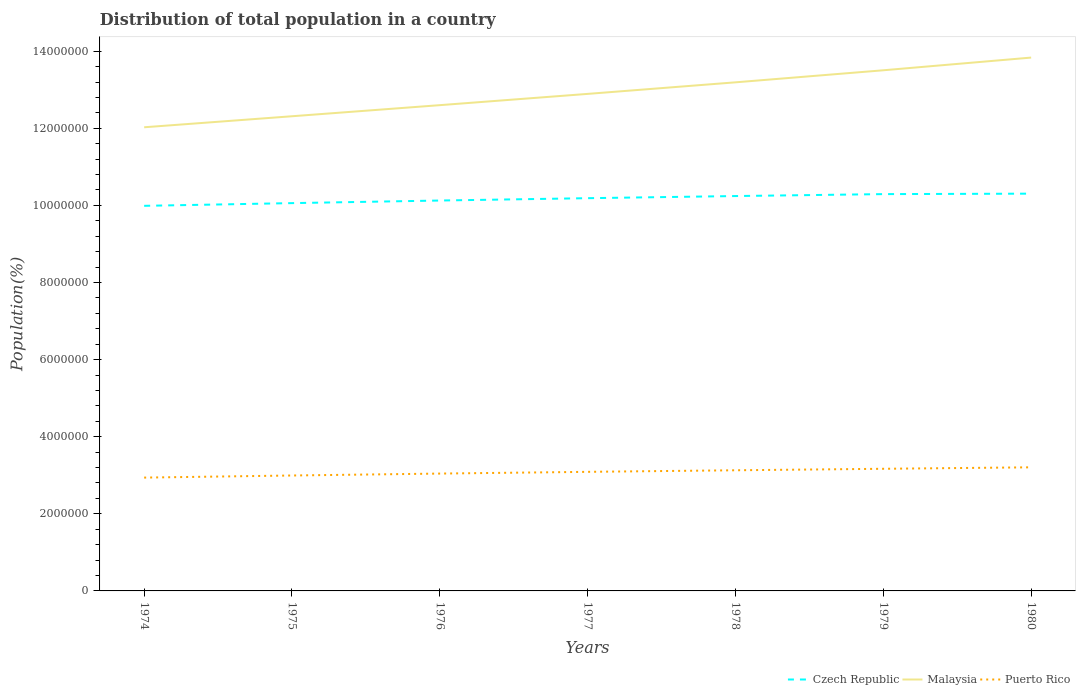How many different coloured lines are there?
Offer a very short reply. 3. Does the line corresponding to Malaysia intersect with the line corresponding to Czech Republic?
Offer a terse response. No. Is the number of lines equal to the number of legend labels?
Offer a terse response. Yes. Across all years, what is the maximum population of in Puerto Rico?
Provide a short and direct response. 2.94e+06. In which year was the population of in Malaysia maximum?
Offer a terse response. 1974. What is the total population of in Puerto Rico in the graph?
Keep it short and to the point. -7.94e+04. What is the difference between the highest and the second highest population of in Malaysia?
Give a very brief answer. 1.81e+06. What is the difference between the highest and the lowest population of in Puerto Rico?
Keep it short and to the point. 4. Is the population of in Czech Republic strictly greater than the population of in Puerto Rico over the years?
Offer a very short reply. No. How many lines are there?
Ensure brevity in your answer.  3. What is the difference between two consecutive major ticks on the Y-axis?
Keep it short and to the point. 2.00e+06. Does the graph contain grids?
Your response must be concise. No. Where does the legend appear in the graph?
Make the answer very short. Bottom right. How are the legend labels stacked?
Your response must be concise. Horizontal. What is the title of the graph?
Ensure brevity in your answer.  Distribution of total population in a country. Does "Lesotho" appear as one of the legend labels in the graph?
Provide a succinct answer. No. What is the label or title of the Y-axis?
Ensure brevity in your answer.  Population(%). What is the Population(%) in Czech Republic in 1974?
Ensure brevity in your answer.  9.99e+06. What is the Population(%) in Malaysia in 1974?
Provide a short and direct response. 1.20e+07. What is the Population(%) in Puerto Rico in 1974?
Make the answer very short. 2.94e+06. What is the Population(%) in Czech Republic in 1975?
Offer a very short reply. 1.01e+07. What is the Population(%) of Malaysia in 1975?
Make the answer very short. 1.23e+07. What is the Population(%) in Puerto Rico in 1975?
Offer a very short reply. 2.99e+06. What is the Population(%) in Czech Republic in 1976?
Keep it short and to the point. 1.01e+07. What is the Population(%) of Malaysia in 1976?
Ensure brevity in your answer.  1.26e+07. What is the Population(%) in Puerto Rico in 1976?
Your answer should be very brief. 3.04e+06. What is the Population(%) in Czech Republic in 1977?
Offer a very short reply. 1.02e+07. What is the Population(%) in Malaysia in 1977?
Ensure brevity in your answer.  1.29e+07. What is the Population(%) of Puerto Rico in 1977?
Give a very brief answer. 3.09e+06. What is the Population(%) of Czech Republic in 1978?
Provide a succinct answer. 1.02e+07. What is the Population(%) of Malaysia in 1978?
Provide a short and direct response. 1.32e+07. What is the Population(%) of Puerto Rico in 1978?
Provide a short and direct response. 3.13e+06. What is the Population(%) in Czech Republic in 1979?
Offer a very short reply. 1.03e+07. What is the Population(%) in Malaysia in 1979?
Provide a short and direct response. 1.35e+07. What is the Population(%) of Puerto Rico in 1979?
Provide a short and direct response. 3.17e+06. What is the Population(%) in Czech Republic in 1980?
Keep it short and to the point. 1.03e+07. What is the Population(%) in Malaysia in 1980?
Give a very brief answer. 1.38e+07. What is the Population(%) of Puerto Rico in 1980?
Your answer should be very brief. 3.21e+06. Across all years, what is the maximum Population(%) of Czech Republic?
Offer a very short reply. 1.03e+07. Across all years, what is the maximum Population(%) of Malaysia?
Provide a succinct answer. 1.38e+07. Across all years, what is the maximum Population(%) of Puerto Rico?
Offer a terse response. 3.21e+06. Across all years, what is the minimum Population(%) of Czech Republic?
Your response must be concise. 9.99e+06. Across all years, what is the minimum Population(%) of Malaysia?
Provide a succinct answer. 1.20e+07. Across all years, what is the minimum Population(%) of Puerto Rico?
Make the answer very short. 2.94e+06. What is the total Population(%) in Czech Republic in the graph?
Ensure brevity in your answer.  7.12e+07. What is the total Population(%) of Malaysia in the graph?
Provide a succinct answer. 9.04e+07. What is the total Population(%) of Puerto Rico in the graph?
Your response must be concise. 2.16e+07. What is the difference between the Population(%) in Czech Republic in 1974 and that in 1975?
Give a very brief answer. -7.02e+04. What is the difference between the Population(%) in Malaysia in 1974 and that in 1975?
Your answer should be compact. -2.86e+05. What is the difference between the Population(%) in Puerto Rico in 1974 and that in 1975?
Your answer should be compact. -5.47e+04. What is the difference between the Population(%) in Czech Republic in 1974 and that in 1976?
Your answer should be very brief. -1.37e+05. What is the difference between the Population(%) of Malaysia in 1974 and that in 1976?
Your response must be concise. -5.74e+05. What is the difference between the Population(%) in Puerto Rico in 1974 and that in 1976?
Provide a short and direct response. -1.05e+05. What is the difference between the Population(%) of Czech Republic in 1974 and that in 1977?
Provide a short and direct response. -1.98e+05. What is the difference between the Population(%) in Malaysia in 1974 and that in 1977?
Ensure brevity in your answer.  -8.66e+05. What is the difference between the Population(%) of Puerto Rico in 1974 and that in 1977?
Give a very brief answer. -1.49e+05. What is the difference between the Population(%) in Czech Republic in 1974 and that in 1978?
Keep it short and to the point. -2.54e+05. What is the difference between the Population(%) of Malaysia in 1974 and that in 1978?
Provide a short and direct response. -1.17e+06. What is the difference between the Population(%) of Puerto Rico in 1974 and that in 1978?
Your answer should be very brief. -1.90e+05. What is the difference between the Population(%) of Czech Republic in 1974 and that in 1979?
Your answer should be compact. -3.04e+05. What is the difference between the Population(%) of Malaysia in 1974 and that in 1979?
Make the answer very short. -1.48e+06. What is the difference between the Population(%) of Puerto Rico in 1974 and that in 1979?
Provide a succinct answer. -2.29e+05. What is the difference between the Population(%) of Czech Republic in 1974 and that in 1980?
Your response must be concise. -3.16e+05. What is the difference between the Population(%) of Malaysia in 1974 and that in 1980?
Your response must be concise. -1.81e+06. What is the difference between the Population(%) in Puerto Rico in 1974 and that in 1980?
Your response must be concise. -2.67e+05. What is the difference between the Population(%) of Czech Republic in 1975 and that in 1976?
Your answer should be very brief. -6.73e+04. What is the difference between the Population(%) in Malaysia in 1975 and that in 1976?
Give a very brief answer. -2.88e+05. What is the difference between the Population(%) of Puerto Rico in 1975 and that in 1976?
Offer a terse response. -4.99e+04. What is the difference between the Population(%) of Czech Republic in 1975 and that in 1977?
Your answer should be compact. -1.28e+05. What is the difference between the Population(%) of Malaysia in 1975 and that in 1977?
Your answer should be very brief. -5.80e+05. What is the difference between the Population(%) of Puerto Rico in 1975 and that in 1977?
Provide a succinct answer. -9.47e+04. What is the difference between the Population(%) in Czech Republic in 1975 and that in 1978?
Make the answer very short. -1.83e+05. What is the difference between the Population(%) in Malaysia in 1975 and that in 1978?
Make the answer very short. -8.80e+05. What is the difference between the Population(%) in Puerto Rico in 1975 and that in 1978?
Make the answer very short. -1.35e+05. What is the difference between the Population(%) in Czech Republic in 1975 and that in 1979?
Your answer should be very brief. -2.34e+05. What is the difference between the Population(%) in Malaysia in 1975 and that in 1979?
Ensure brevity in your answer.  -1.19e+06. What is the difference between the Population(%) in Puerto Rico in 1975 and that in 1979?
Provide a short and direct response. -1.74e+05. What is the difference between the Population(%) in Czech Republic in 1975 and that in 1980?
Make the answer very short. -2.46e+05. What is the difference between the Population(%) of Malaysia in 1975 and that in 1980?
Give a very brief answer. -1.52e+06. What is the difference between the Population(%) in Puerto Rico in 1975 and that in 1980?
Provide a succinct answer. -2.12e+05. What is the difference between the Population(%) of Czech Republic in 1976 and that in 1977?
Offer a terse response. -6.08e+04. What is the difference between the Population(%) in Malaysia in 1976 and that in 1977?
Your answer should be very brief. -2.92e+05. What is the difference between the Population(%) of Puerto Rico in 1976 and that in 1977?
Give a very brief answer. -4.48e+04. What is the difference between the Population(%) in Czech Republic in 1976 and that in 1978?
Provide a succinct answer. -1.16e+05. What is the difference between the Population(%) of Malaysia in 1976 and that in 1978?
Provide a succinct answer. -5.92e+05. What is the difference between the Population(%) of Puerto Rico in 1976 and that in 1978?
Offer a very short reply. -8.56e+04. What is the difference between the Population(%) of Czech Republic in 1976 and that in 1979?
Your answer should be compact. -1.66e+05. What is the difference between the Population(%) in Malaysia in 1976 and that in 1979?
Offer a very short reply. -9.05e+05. What is the difference between the Population(%) of Puerto Rico in 1976 and that in 1979?
Offer a very short reply. -1.24e+05. What is the difference between the Population(%) of Czech Republic in 1976 and that in 1980?
Your response must be concise. -1.78e+05. What is the difference between the Population(%) in Malaysia in 1976 and that in 1980?
Provide a short and direct response. -1.23e+06. What is the difference between the Population(%) in Puerto Rico in 1976 and that in 1980?
Keep it short and to the point. -1.62e+05. What is the difference between the Population(%) in Czech Republic in 1977 and that in 1978?
Ensure brevity in your answer.  -5.53e+04. What is the difference between the Population(%) in Malaysia in 1977 and that in 1978?
Make the answer very short. -3.00e+05. What is the difference between the Population(%) of Puerto Rico in 1977 and that in 1978?
Offer a terse response. -4.07e+04. What is the difference between the Population(%) in Czech Republic in 1977 and that in 1979?
Your response must be concise. -1.06e+05. What is the difference between the Population(%) in Malaysia in 1977 and that in 1979?
Offer a terse response. -6.13e+05. What is the difference between the Population(%) in Puerto Rico in 1977 and that in 1979?
Offer a very short reply. -7.94e+04. What is the difference between the Population(%) of Czech Republic in 1977 and that in 1980?
Keep it short and to the point. -1.17e+05. What is the difference between the Population(%) in Malaysia in 1977 and that in 1980?
Provide a short and direct response. -9.42e+05. What is the difference between the Population(%) in Puerto Rico in 1977 and that in 1980?
Your response must be concise. -1.17e+05. What is the difference between the Population(%) of Czech Republic in 1978 and that in 1979?
Keep it short and to the point. -5.02e+04. What is the difference between the Population(%) of Malaysia in 1978 and that in 1979?
Keep it short and to the point. -3.13e+05. What is the difference between the Population(%) of Puerto Rico in 1978 and that in 1979?
Give a very brief answer. -3.87e+04. What is the difference between the Population(%) of Czech Republic in 1978 and that in 1980?
Your answer should be compact. -6.21e+04. What is the difference between the Population(%) in Malaysia in 1978 and that in 1980?
Your response must be concise. -6.42e+05. What is the difference between the Population(%) of Puerto Rico in 1978 and that in 1980?
Make the answer very short. -7.66e+04. What is the difference between the Population(%) in Czech Republic in 1979 and that in 1980?
Provide a short and direct response. -1.19e+04. What is the difference between the Population(%) of Malaysia in 1979 and that in 1980?
Give a very brief answer. -3.29e+05. What is the difference between the Population(%) in Puerto Rico in 1979 and that in 1980?
Provide a succinct answer. -3.79e+04. What is the difference between the Population(%) of Czech Republic in 1974 and the Population(%) of Malaysia in 1975?
Provide a succinct answer. -2.32e+06. What is the difference between the Population(%) of Czech Republic in 1974 and the Population(%) of Puerto Rico in 1975?
Give a very brief answer. 6.99e+06. What is the difference between the Population(%) in Malaysia in 1974 and the Population(%) in Puerto Rico in 1975?
Offer a very short reply. 9.03e+06. What is the difference between the Population(%) in Czech Republic in 1974 and the Population(%) in Malaysia in 1976?
Provide a succinct answer. -2.61e+06. What is the difference between the Population(%) in Czech Republic in 1974 and the Population(%) in Puerto Rico in 1976?
Your response must be concise. 6.94e+06. What is the difference between the Population(%) of Malaysia in 1974 and the Population(%) of Puerto Rico in 1976?
Provide a succinct answer. 8.98e+06. What is the difference between the Population(%) in Czech Republic in 1974 and the Population(%) in Malaysia in 1977?
Give a very brief answer. -2.90e+06. What is the difference between the Population(%) in Czech Republic in 1974 and the Population(%) in Puerto Rico in 1977?
Offer a very short reply. 6.90e+06. What is the difference between the Population(%) in Malaysia in 1974 and the Population(%) in Puerto Rico in 1977?
Offer a very short reply. 8.94e+06. What is the difference between the Population(%) of Czech Republic in 1974 and the Population(%) of Malaysia in 1978?
Offer a very short reply. -3.20e+06. What is the difference between the Population(%) of Czech Republic in 1974 and the Population(%) of Puerto Rico in 1978?
Your answer should be compact. 6.86e+06. What is the difference between the Population(%) in Malaysia in 1974 and the Population(%) in Puerto Rico in 1978?
Provide a succinct answer. 8.90e+06. What is the difference between the Population(%) in Czech Republic in 1974 and the Population(%) in Malaysia in 1979?
Your response must be concise. -3.52e+06. What is the difference between the Population(%) of Czech Republic in 1974 and the Population(%) of Puerto Rico in 1979?
Offer a terse response. 6.82e+06. What is the difference between the Population(%) in Malaysia in 1974 and the Population(%) in Puerto Rico in 1979?
Your answer should be very brief. 8.86e+06. What is the difference between the Population(%) of Czech Republic in 1974 and the Population(%) of Malaysia in 1980?
Provide a short and direct response. -3.85e+06. What is the difference between the Population(%) in Czech Republic in 1974 and the Population(%) in Puerto Rico in 1980?
Your answer should be very brief. 6.78e+06. What is the difference between the Population(%) of Malaysia in 1974 and the Population(%) of Puerto Rico in 1980?
Make the answer very short. 8.82e+06. What is the difference between the Population(%) of Czech Republic in 1975 and the Population(%) of Malaysia in 1976?
Provide a succinct answer. -2.54e+06. What is the difference between the Population(%) of Czech Republic in 1975 and the Population(%) of Puerto Rico in 1976?
Your answer should be very brief. 7.01e+06. What is the difference between the Population(%) in Malaysia in 1975 and the Population(%) in Puerto Rico in 1976?
Your answer should be compact. 9.27e+06. What is the difference between the Population(%) in Czech Republic in 1975 and the Population(%) in Malaysia in 1977?
Provide a succinct answer. -2.83e+06. What is the difference between the Population(%) in Czech Republic in 1975 and the Population(%) in Puerto Rico in 1977?
Give a very brief answer. 6.97e+06. What is the difference between the Population(%) of Malaysia in 1975 and the Population(%) of Puerto Rico in 1977?
Your answer should be compact. 9.22e+06. What is the difference between the Population(%) in Czech Republic in 1975 and the Population(%) in Malaysia in 1978?
Your answer should be very brief. -3.13e+06. What is the difference between the Population(%) in Czech Republic in 1975 and the Population(%) in Puerto Rico in 1978?
Give a very brief answer. 6.93e+06. What is the difference between the Population(%) in Malaysia in 1975 and the Population(%) in Puerto Rico in 1978?
Provide a succinct answer. 9.18e+06. What is the difference between the Population(%) in Czech Republic in 1975 and the Population(%) in Malaysia in 1979?
Your response must be concise. -3.45e+06. What is the difference between the Population(%) in Czech Republic in 1975 and the Population(%) in Puerto Rico in 1979?
Your response must be concise. 6.89e+06. What is the difference between the Population(%) of Malaysia in 1975 and the Population(%) of Puerto Rico in 1979?
Ensure brevity in your answer.  9.14e+06. What is the difference between the Population(%) of Czech Republic in 1975 and the Population(%) of Malaysia in 1980?
Give a very brief answer. -3.78e+06. What is the difference between the Population(%) in Czech Republic in 1975 and the Population(%) in Puerto Rico in 1980?
Your response must be concise. 6.85e+06. What is the difference between the Population(%) of Malaysia in 1975 and the Population(%) of Puerto Rico in 1980?
Give a very brief answer. 9.11e+06. What is the difference between the Population(%) of Czech Republic in 1976 and the Population(%) of Malaysia in 1977?
Offer a very short reply. -2.77e+06. What is the difference between the Population(%) in Czech Republic in 1976 and the Population(%) in Puerto Rico in 1977?
Your answer should be compact. 7.04e+06. What is the difference between the Population(%) in Malaysia in 1976 and the Population(%) in Puerto Rico in 1977?
Keep it short and to the point. 9.51e+06. What is the difference between the Population(%) of Czech Republic in 1976 and the Population(%) of Malaysia in 1978?
Offer a very short reply. -3.07e+06. What is the difference between the Population(%) of Czech Republic in 1976 and the Population(%) of Puerto Rico in 1978?
Your answer should be compact. 7.00e+06. What is the difference between the Population(%) in Malaysia in 1976 and the Population(%) in Puerto Rico in 1978?
Your answer should be very brief. 9.47e+06. What is the difference between the Population(%) of Czech Republic in 1976 and the Population(%) of Malaysia in 1979?
Give a very brief answer. -3.38e+06. What is the difference between the Population(%) in Czech Republic in 1976 and the Population(%) in Puerto Rico in 1979?
Offer a very short reply. 6.96e+06. What is the difference between the Population(%) in Malaysia in 1976 and the Population(%) in Puerto Rico in 1979?
Provide a short and direct response. 9.43e+06. What is the difference between the Population(%) in Czech Republic in 1976 and the Population(%) in Malaysia in 1980?
Provide a succinct answer. -3.71e+06. What is the difference between the Population(%) of Czech Republic in 1976 and the Population(%) of Puerto Rico in 1980?
Make the answer very short. 6.92e+06. What is the difference between the Population(%) in Malaysia in 1976 and the Population(%) in Puerto Rico in 1980?
Your answer should be compact. 9.39e+06. What is the difference between the Population(%) of Czech Republic in 1977 and the Population(%) of Malaysia in 1978?
Your answer should be compact. -3.00e+06. What is the difference between the Population(%) of Czech Republic in 1977 and the Population(%) of Puerto Rico in 1978?
Your answer should be very brief. 7.06e+06. What is the difference between the Population(%) in Malaysia in 1977 and the Population(%) in Puerto Rico in 1978?
Offer a very short reply. 9.76e+06. What is the difference between the Population(%) of Czech Republic in 1977 and the Population(%) of Malaysia in 1979?
Make the answer very short. -3.32e+06. What is the difference between the Population(%) in Czech Republic in 1977 and the Population(%) in Puerto Rico in 1979?
Provide a short and direct response. 7.02e+06. What is the difference between the Population(%) in Malaysia in 1977 and the Population(%) in Puerto Rico in 1979?
Make the answer very short. 9.72e+06. What is the difference between the Population(%) of Czech Republic in 1977 and the Population(%) of Malaysia in 1980?
Give a very brief answer. -3.65e+06. What is the difference between the Population(%) in Czech Republic in 1977 and the Population(%) in Puerto Rico in 1980?
Your answer should be very brief. 6.98e+06. What is the difference between the Population(%) of Malaysia in 1977 and the Population(%) of Puerto Rico in 1980?
Give a very brief answer. 9.69e+06. What is the difference between the Population(%) of Czech Republic in 1978 and the Population(%) of Malaysia in 1979?
Your response must be concise. -3.26e+06. What is the difference between the Population(%) of Czech Republic in 1978 and the Population(%) of Puerto Rico in 1979?
Give a very brief answer. 7.07e+06. What is the difference between the Population(%) in Malaysia in 1978 and the Population(%) in Puerto Rico in 1979?
Make the answer very short. 1.00e+07. What is the difference between the Population(%) of Czech Republic in 1978 and the Population(%) of Malaysia in 1980?
Your answer should be very brief. -3.59e+06. What is the difference between the Population(%) in Czech Republic in 1978 and the Population(%) in Puerto Rico in 1980?
Ensure brevity in your answer.  7.04e+06. What is the difference between the Population(%) in Malaysia in 1978 and the Population(%) in Puerto Rico in 1980?
Your response must be concise. 9.99e+06. What is the difference between the Population(%) in Czech Republic in 1979 and the Population(%) in Malaysia in 1980?
Your answer should be compact. -3.54e+06. What is the difference between the Population(%) in Czech Republic in 1979 and the Population(%) in Puerto Rico in 1980?
Make the answer very short. 7.09e+06. What is the difference between the Population(%) of Malaysia in 1979 and the Population(%) of Puerto Rico in 1980?
Give a very brief answer. 1.03e+07. What is the average Population(%) in Czech Republic per year?
Provide a short and direct response. 1.02e+07. What is the average Population(%) in Malaysia per year?
Keep it short and to the point. 1.29e+07. What is the average Population(%) in Puerto Rico per year?
Provide a succinct answer. 3.08e+06. In the year 1974, what is the difference between the Population(%) in Czech Republic and Population(%) in Malaysia?
Offer a terse response. -2.04e+06. In the year 1974, what is the difference between the Population(%) in Czech Republic and Population(%) in Puerto Rico?
Offer a terse response. 7.05e+06. In the year 1974, what is the difference between the Population(%) of Malaysia and Population(%) of Puerto Rico?
Offer a terse response. 9.09e+06. In the year 1975, what is the difference between the Population(%) in Czech Republic and Population(%) in Malaysia?
Offer a very short reply. -2.25e+06. In the year 1975, what is the difference between the Population(%) in Czech Republic and Population(%) in Puerto Rico?
Your answer should be compact. 7.06e+06. In the year 1975, what is the difference between the Population(%) in Malaysia and Population(%) in Puerto Rico?
Your answer should be very brief. 9.32e+06. In the year 1976, what is the difference between the Population(%) in Czech Republic and Population(%) in Malaysia?
Provide a short and direct response. -2.47e+06. In the year 1976, what is the difference between the Population(%) of Czech Republic and Population(%) of Puerto Rico?
Your response must be concise. 7.08e+06. In the year 1976, what is the difference between the Population(%) of Malaysia and Population(%) of Puerto Rico?
Ensure brevity in your answer.  9.56e+06. In the year 1977, what is the difference between the Population(%) in Czech Republic and Population(%) in Malaysia?
Make the answer very short. -2.70e+06. In the year 1977, what is the difference between the Population(%) of Czech Republic and Population(%) of Puerto Rico?
Offer a very short reply. 7.10e+06. In the year 1977, what is the difference between the Population(%) in Malaysia and Population(%) in Puerto Rico?
Make the answer very short. 9.80e+06. In the year 1978, what is the difference between the Population(%) in Czech Republic and Population(%) in Malaysia?
Give a very brief answer. -2.95e+06. In the year 1978, what is the difference between the Population(%) in Czech Republic and Population(%) in Puerto Rico?
Your response must be concise. 7.11e+06. In the year 1978, what is the difference between the Population(%) of Malaysia and Population(%) of Puerto Rico?
Offer a very short reply. 1.01e+07. In the year 1979, what is the difference between the Population(%) of Czech Republic and Population(%) of Malaysia?
Provide a short and direct response. -3.21e+06. In the year 1979, what is the difference between the Population(%) of Czech Republic and Population(%) of Puerto Rico?
Provide a succinct answer. 7.12e+06. In the year 1979, what is the difference between the Population(%) in Malaysia and Population(%) in Puerto Rico?
Give a very brief answer. 1.03e+07. In the year 1980, what is the difference between the Population(%) in Czech Republic and Population(%) in Malaysia?
Provide a succinct answer. -3.53e+06. In the year 1980, what is the difference between the Population(%) of Czech Republic and Population(%) of Puerto Rico?
Provide a short and direct response. 7.10e+06. In the year 1980, what is the difference between the Population(%) in Malaysia and Population(%) in Puerto Rico?
Your answer should be compact. 1.06e+07. What is the ratio of the Population(%) of Czech Republic in 1974 to that in 1975?
Offer a very short reply. 0.99. What is the ratio of the Population(%) of Malaysia in 1974 to that in 1975?
Your response must be concise. 0.98. What is the ratio of the Population(%) of Puerto Rico in 1974 to that in 1975?
Ensure brevity in your answer.  0.98. What is the ratio of the Population(%) of Czech Republic in 1974 to that in 1976?
Keep it short and to the point. 0.99. What is the ratio of the Population(%) in Malaysia in 1974 to that in 1976?
Offer a terse response. 0.95. What is the ratio of the Population(%) in Puerto Rico in 1974 to that in 1976?
Offer a very short reply. 0.97. What is the ratio of the Population(%) in Czech Republic in 1974 to that in 1977?
Offer a terse response. 0.98. What is the ratio of the Population(%) of Malaysia in 1974 to that in 1977?
Offer a terse response. 0.93. What is the ratio of the Population(%) in Puerto Rico in 1974 to that in 1977?
Keep it short and to the point. 0.95. What is the ratio of the Population(%) of Czech Republic in 1974 to that in 1978?
Keep it short and to the point. 0.98. What is the ratio of the Population(%) in Malaysia in 1974 to that in 1978?
Your answer should be very brief. 0.91. What is the ratio of the Population(%) of Puerto Rico in 1974 to that in 1978?
Your response must be concise. 0.94. What is the ratio of the Population(%) in Czech Republic in 1974 to that in 1979?
Give a very brief answer. 0.97. What is the ratio of the Population(%) in Malaysia in 1974 to that in 1979?
Offer a terse response. 0.89. What is the ratio of the Population(%) in Puerto Rico in 1974 to that in 1979?
Keep it short and to the point. 0.93. What is the ratio of the Population(%) in Czech Republic in 1974 to that in 1980?
Keep it short and to the point. 0.97. What is the ratio of the Population(%) in Malaysia in 1974 to that in 1980?
Make the answer very short. 0.87. What is the ratio of the Population(%) of Puerto Rico in 1974 to that in 1980?
Your response must be concise. 0.92. What is the ratio of the Population(%) in Czech Republic in 1975 to that in 1976?
Provide a short and direct response. 0.99. What is the ratio of the Population(%) of Malaysia in 1975 to that in 1976?
Your response must be concise. 0.98. What is the ratio of the Population(%) in Puerto Rico in 1975 to that in 1976?
Provide a succinct answer. 0.98. What is the ratio of the Population(%) of Czech Republic in 1975 to that in 1977?
Ensure brevity in your answer.  0.99. What is the ratio of the Population(%) of Malaysia in 1975 to that in 1977?
Offer a terse response. 0.95. What is the ratio of the Population(%) of Puerto Rico in 1975 to that in 1977?
Offer a very short reply. 0.97. What is the ratio of the Population(%) of Czech Republic in 1975 to that in 1978?
Your response must be concise. 0.98. What is the ratio of the Population(%) in Puerto Rico in 1975 to that in 1978?
Provide a succinct answer. 0.96. What is the ratio of the Population(%) of Czech Republic in 1975 to that in 1979?
Your answer should be very brief. 0.98. What is the ratio of the Population(%) in Malaysia in 1975 to that in 1979?
Give a very brief answer. 0.91. What is the ratio of the Population(%) in Puerto Rico in 1975 to that in 1979?
Ensure brevity in your answer.  0.94. What is the ratio of the Population(%) of Czech Republic in 1975 to that in 1980?
Provide a short and direct response. 0.98. What is the ratio of the Population(%) in Malaysia in 1975 to that in 1980?
Offer a terse response. 0.89. What is the ratio of the Population(%) of Puerto Rico in 1975 to that in 1980?
Offer a very short reply. 0.93. What is the ratio of the Population(%) in Malaysia in 1976 to that in 1977?
Give a very brief answer. 0.98. What is the ratio of the Population(%) of Puerto Rico in 1976 to that in 1977?
Your answer should be very brief. 0.99. What is the ratio of the Population(%) in Czech Republic in 1976 to that in 1978?
Your answer should be compact. 0.99. What is the ratio of the Population(%) of Malaysia in 1976 to that in 1978?
Your answer should be compact. 0.96. What is the ratio of the Population(%) in Puerto Rico in 1976 to that in 1978?
Give a very brief answer. 0.97. What is the ratio of the Population(%) in Czech Republic in 1976 to that in 1979?
Ensure brevity in your answer.  0.98. What is the ratio of the Population(%) in Malaysia in 1976 to that in 1979?
Offer a very short reply. 0.93. What is the ratio of the Population(%) of Puerto Rico in 1976 to that in 1979?
Your answer should be very brief. 0.96. What is the ratio of the Population(%) of Czech Republic in 1976 to that in 1980?
Provide a short and direct response. 0.98. What is the ratio of the Population(%) of Malaysia in 1976 to that in 1980?
Provide a short and direct response. 0.91. What is the ratio of the Population(%) of Puerto Rico in 1976 to that in 1980?
Provide a short and direct response. 0.95. What is the ratio of the Population(%) of Czech Republic in 1977 to that in 1978?
Your answer should be very brief. 0.99. What is the ratio of the Population(%) of Malaysia in 1977 to that in 1978?
Keep it short and to the point. 0.98. What is the ratio of the Population(%) of Puerto Rico in 1977 to that in 1978?
Make the answer very short. 0.99. What is the ratio of the Population(%) in Malaysia in 1977 to that in 1979?
Your answer should be very brief. 0.95. What is the ratio of the Population(%) of Puerto Rico in 1977 to that in 1979?
Offer a terse response. 0.97. What is the ratio of the Population(%) of Malaysia in 1977 to that in 1980?
Offer a very short reply. 0.93. What is the ratio of the Population(%) in Puerto Rico in 1977 to that in 1980?
Your response must be concise. 0.96. What is the ratio of the Population(%) in Czech Republic in 1978 to that in 1979?
Your answer should be very brief. 1. What is the ratio of the Population(%) of Malaysia in 1978 to that in 1979?
Keep it short and to the point. 0.98. What is the ratio of the Population(%) of Czech Republic in 1978 to that in 1980?
Your answer should be very brief. 0.99. What is the ratio of the Population(%) in Malaysia in 1978 to that in 1980?
Ensure brevity in your answer.  0.95. What is the ratio of the Population(%) in Puerto Rico in 1978 to that in 1980?
Your answer should be compact. 0.98. What is the ratio of the Population(%) of Malaysia in 1979 to that in 1980?
Ensure brevity in your answer.  0.98. What is the difference between the highest and the second highest Population(%) of Czech Republic?
Offer a terse response. 1.19e+04. What is the difference between the highest and the second highest Population(%) of Malaysia?
Give a very brief answer. 3.29e+05. What is the difference between the highest and the second highest Population(%) of Puerto Rico?
Keep it short and to the point. 3.79e+04. What is the difference between the highest and the lowest Population(%) of Czech Republic?
Your response must be concise. 3.16e+05. What is the difference between the highest and the lowest Population(%) in Malaysia?
Give a very brief answer. 1.81e+06. What is the difference between the highest and the lowest Population(%) of Puerto Rico?
Offer a very short reply. 2.67e+05. 